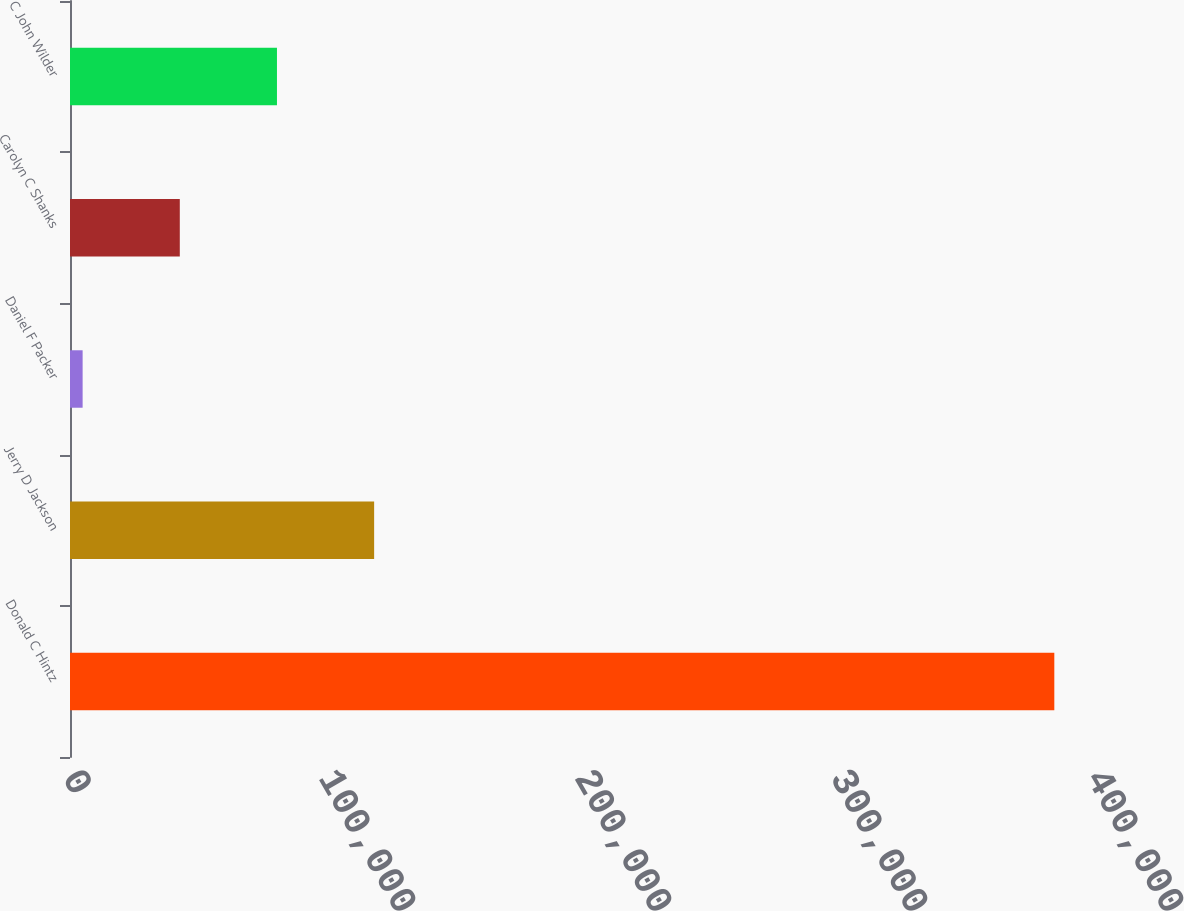Convert chart to OTSL. <chart><loc_0><loc_0><loc_500><loc_500><bar_chart><fcel>Donald C Hintz<fcel>Jerry D Jackson<fcel>Daniel F Packer<fcel>Carolyn C Shanks<fcel>C John Wilder<nl><fcel>384499<fcel>118803<fcel>4933<fcel>42889.6<fcel>80846.2<nl></chart> 